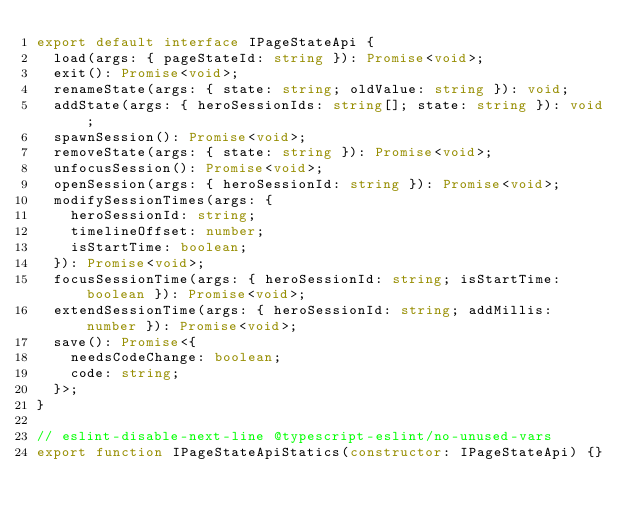<code> <loc_0><loc_0><loc_500><loc_500><_TypeScript_>export default interface IPageStateApi {
  load(args: { pageStateId: string }): Promise<void>;
  exit(): Promise<void>;
  renameState(args: { state: string; oldValue: string }): void;
  addState(args: { heroSessionIds: string[]; state: string }): void;
  spawnSession(): Promise<void>;
  removeState(args: { state: string }): Promise<void>;
  unfocusSession(): Promise<void>;
  openSession(args: { heroSessionId: string }): Promise<void>;
  modifySessionTimes(args: {
    heroSessionId: string;
    timelineOffset: number;
    isStartTime: boolean;
  }): Promise<void>;
  focusSessionTime(args: { heroSessionId: string; isStartTime: boolean }): Promise<void>;
  extendSessionTime(args: { heroSessionId: string; addMillis: number }): Promise<void>;
  save(): Promise<{
    needsCodeChange: boolean;
    code: string;
  }>;
}

// eslint-disable-next-line @typescript-eslint/no-unused-vars
export function IPageStateApiStatics(constructor: IPageStateApi) {}
</code> 